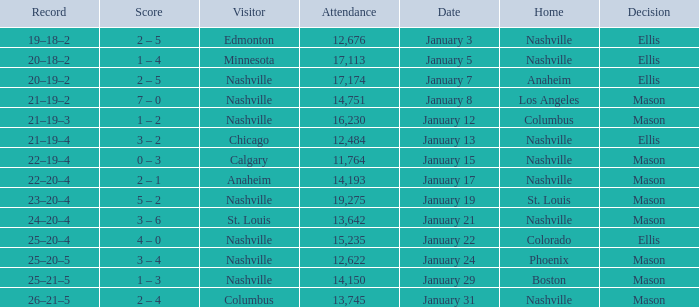On January 29, who had the decision of Mason? Nashville. 